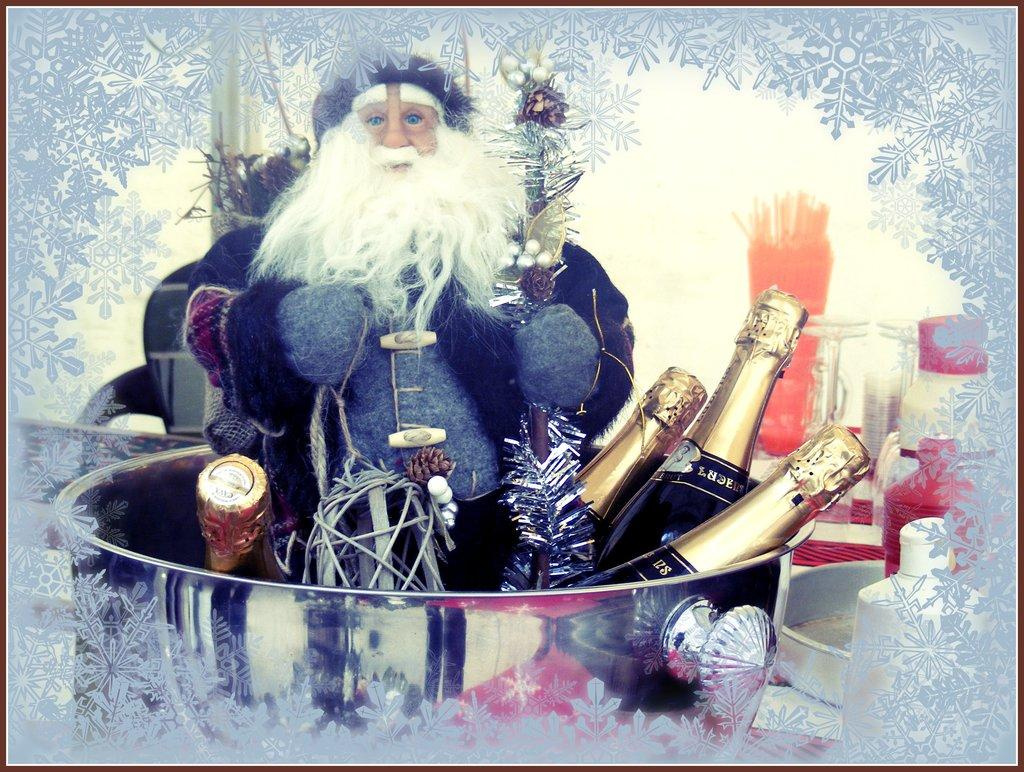What can be seen hanging on the wall in the image? There is a poster in the image. What type of toy is present in the image? There is a Santa Claus toy in the image. What type of containers are visible in the image? There are bottles in the image. What other objects can be seen on the right side of the image? There are other objects on the right side of the image, but their specific details are not mentioned in the provided facts. What type of twig is being used for the activity in the image? There is no twig or activity present in the image. Can you describe the sail in the image? There is no sail present in the image. 